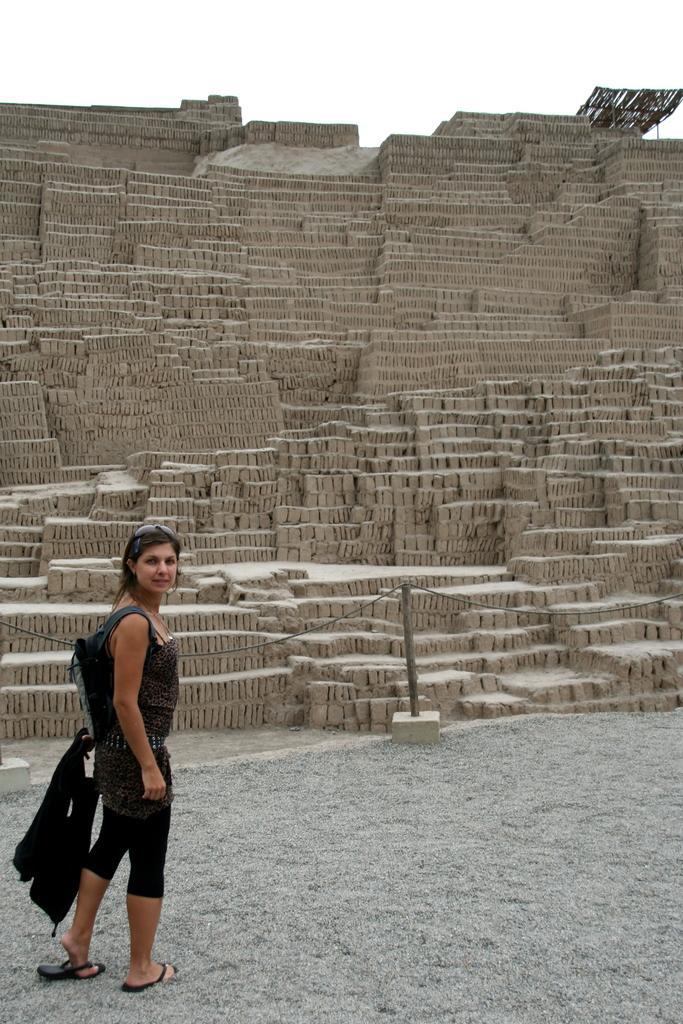Can you describe this image briefly? In this image we can see a woman wearing goggles on her head and carrying a bag is standing on the ground. In the center of the image we can see a pole with a rope. In the background, we can see a wall made with stone and the sky. 